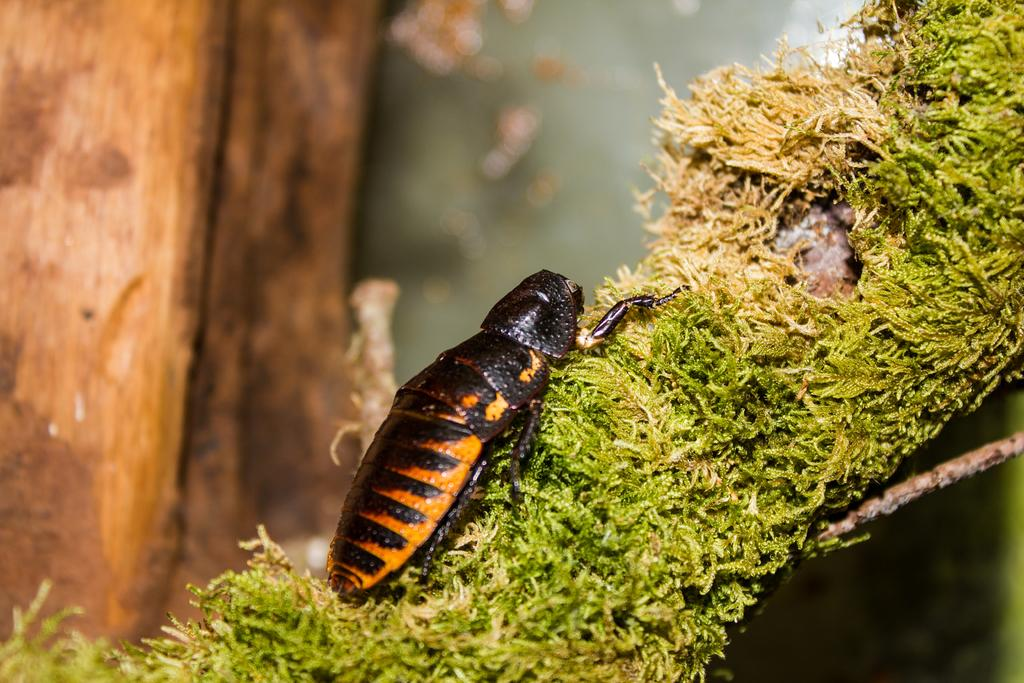What type of creature is present in the image? There is an insect in the image. Where is the insect located? The insect is on the grass. What can be seen in the background of the image? There are wooden objects in the background of the image. What type of hen can be seen playing with a baseball in the image? There is no hen or baseball present in the image; it features an insect on the grass and wooden objects in the background. 